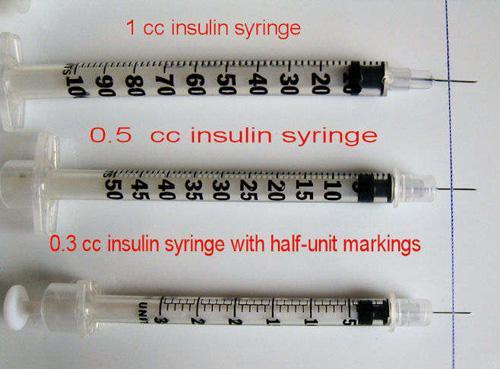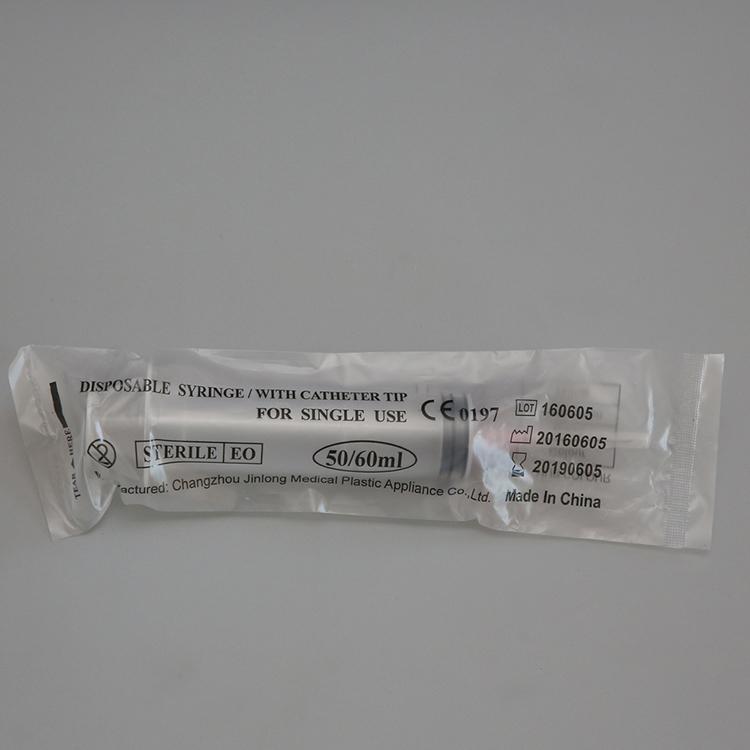The first image is the image on the left, the second image is the image on the right. Considering the images on both sides, is "There are two more syringes on the right side" valid? Answer yes or no. No. The first image is the image on the left, the second image is the image on the right. Analyze the images presented: Is the assertion "There are four unbagged syringes, one in one image and three in the other." valid? Answer yes or no. No. 